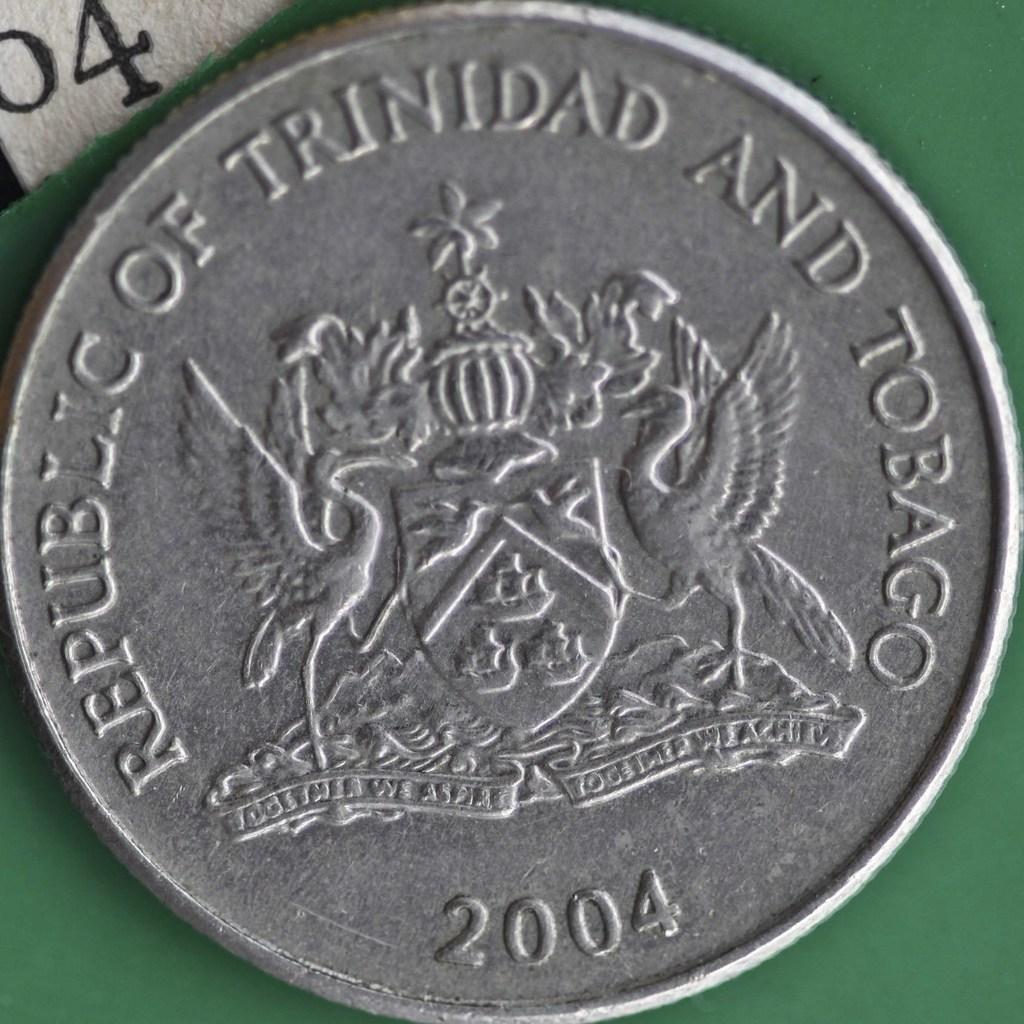<image>
Present a compact description of the photo's key features. A coin from 2004 that reads Republic of Trinidad and Tobago 